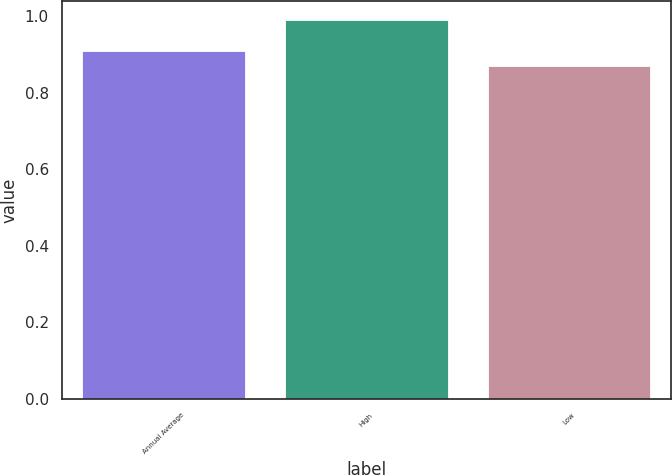<chart> <loc_0><loc_0><loc_500><loc_500><bar_chart><fcel>Annual Average<fcel>High<fcel>Low<nl><fcel>0.91<fcel>0.99<fcel>0.87<nl></chart> 